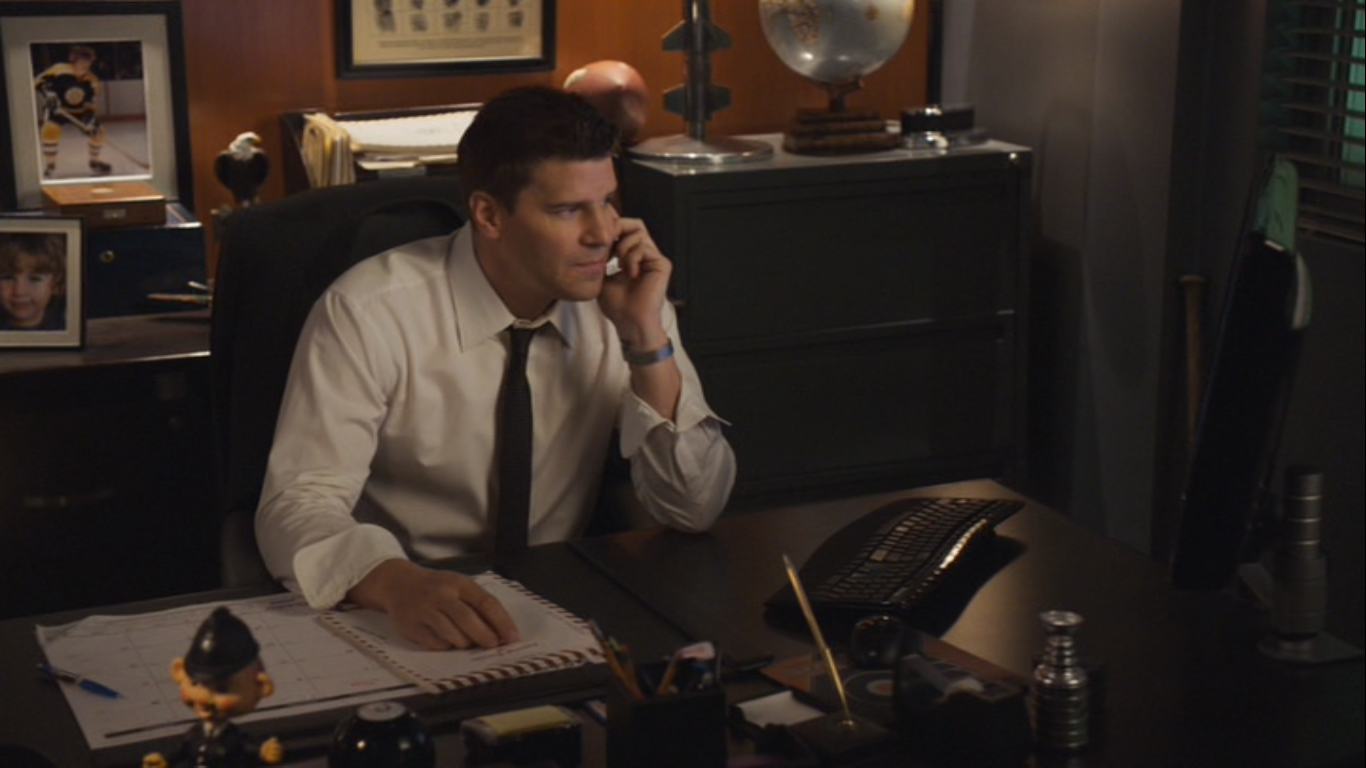What are the key elements in this picture? In this image, we see an actor portraying a professional character, possibly a detective or special agent, seated at an office desk. Key details include the actor holding a phone to his ear with his right hand, indicating he is engaged in a phone conversation. His left hand rests on a notepad, suggesting he may be taking notes. He is dressed in a white dress shirt and a dark tie, adding to his professional appearance. The desk is adorned with various objects such as a keyboard, reinforcing the technological aspect of his work, a globe symbolizing global investigations, and a photo of a child, hinting at his family life. The office setting is further emphasized by the dark blue backdrop, window, and bookshelf in the background. Overall, this image vividly depicts the actor in a serious and professional role, fully immersed in his work environment. 